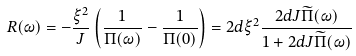<formula> <loc_0><loc_0><loc_500><loc_500>R ( \omega ) = - \frac { \xi ^ { 2 } } { J } \left ( \frac { 1 } { \Pi ( \omega ) } - \frac { 1 } { \Pi ( 0 ) } \right ) = 2 d \xi ^ { 2 } \frac { 2 d J \widetilde { \Pi } ( \omega ) } { 1 + 2 d J \widetilde { \Pi } ( \omega ) }</formula> 